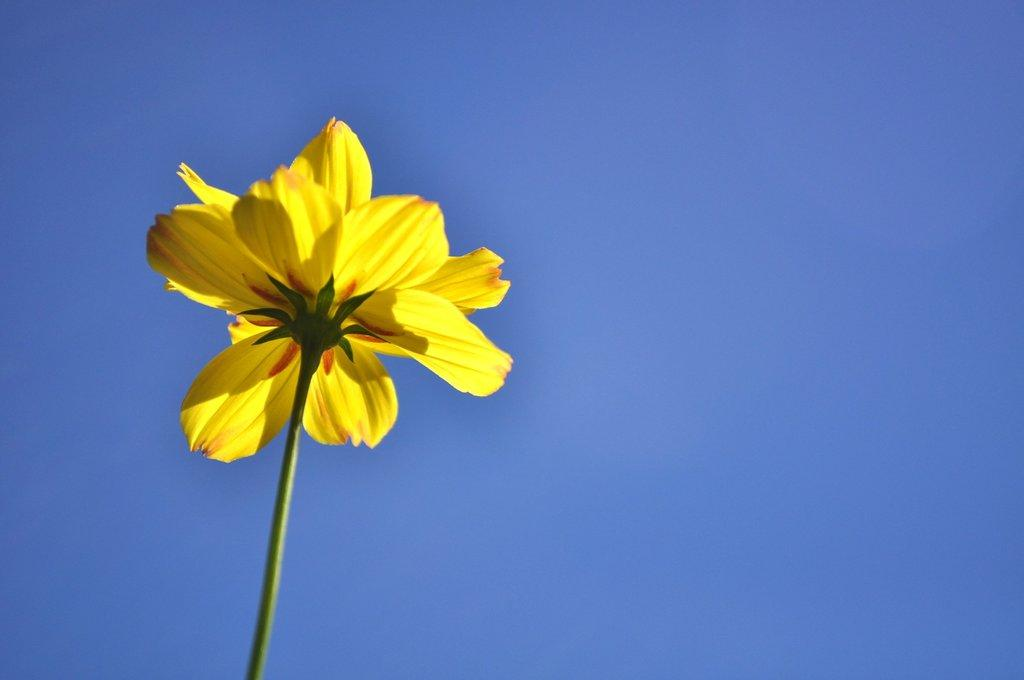What type of flower is in the image? There is a yellow flower in the image. What color is the background of the image? The background of the image is blue. What type of cat is performing an operation on the gold in the image? There is no cat, operation, or gold present in the image. 